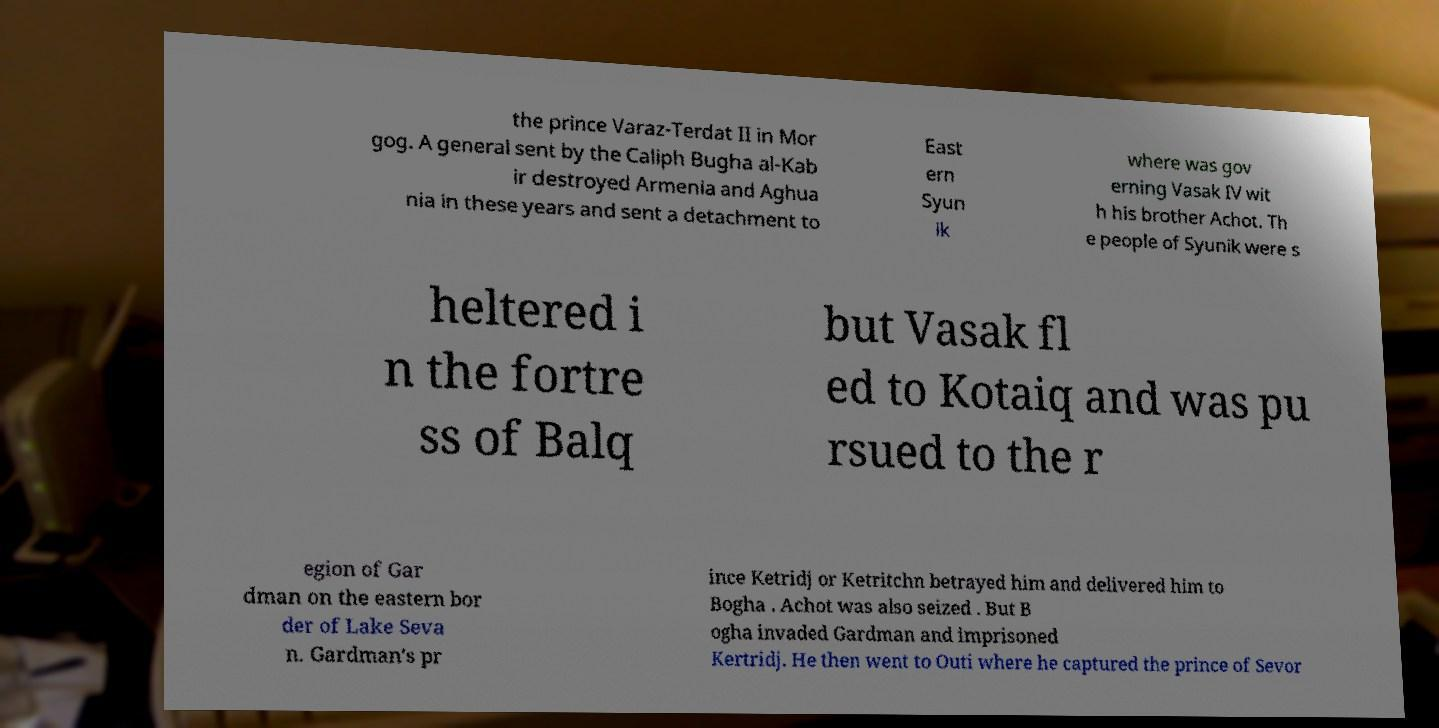Could you extract and type out the text from this image? the prince Varaz-Terdat II in Mor gog. A general sent by the Caliph Bugha al-Kab ir destroyed Armenia and Aghua nia in these years and sent a detachment to East ern Syun ik where was gov erning Vasak IV wit h his brother Achot. Th e people of Syunik were s heltered i n the fortre ss of Balq but Vasak fl ed to Kotaiq and was pu rsued to the r egion of Gar dman on the eastern bor der of Lake Seva n. Gardman's pr ince Ketridj or Ketritchn betrayed him and delivered him to Bogha . Achot was also seized . But B ogha invaded Gardman and imprisoned Kertridj. He then went to Outi where he captured the prince of Sevor 